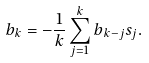Convert formula to latex. <formula><loc_0><loc_0><loc_500><loc_500>b _ { k } = - \frac { 1 } { k } \sum _ { j = 1 } ^ { k } b _ { k - j } s _ { j } .</formula> 